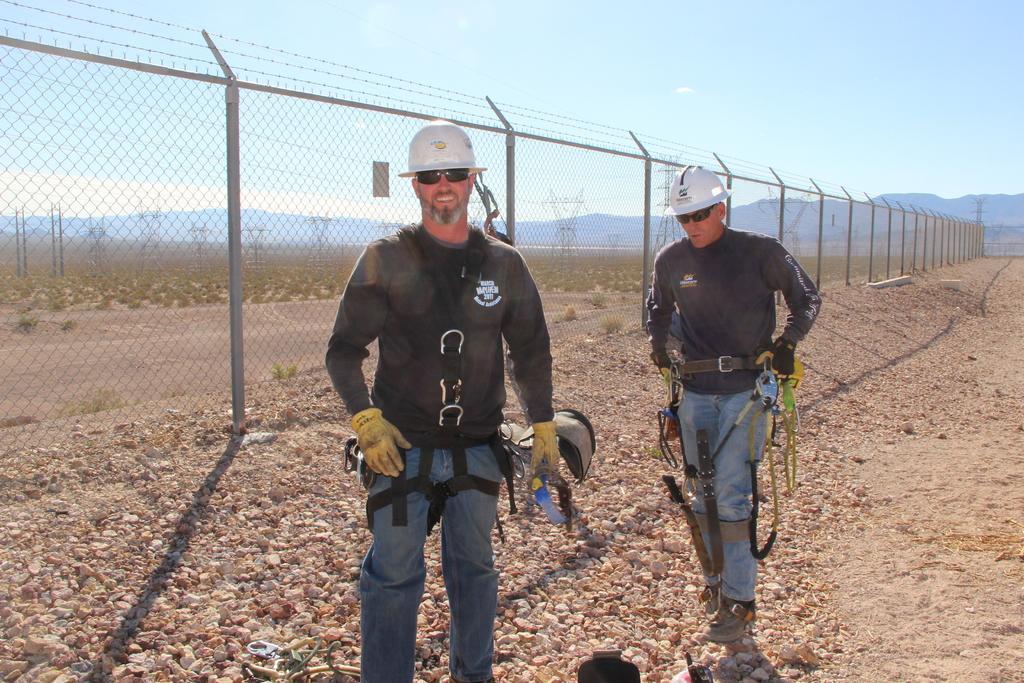In one or two sentences, can you explain what this image depicts? In this image in the front there are persons standing. On the ground there are stones. In the center there is a fence. In the background there are mountains, there are plants and the sky is cloudy. 